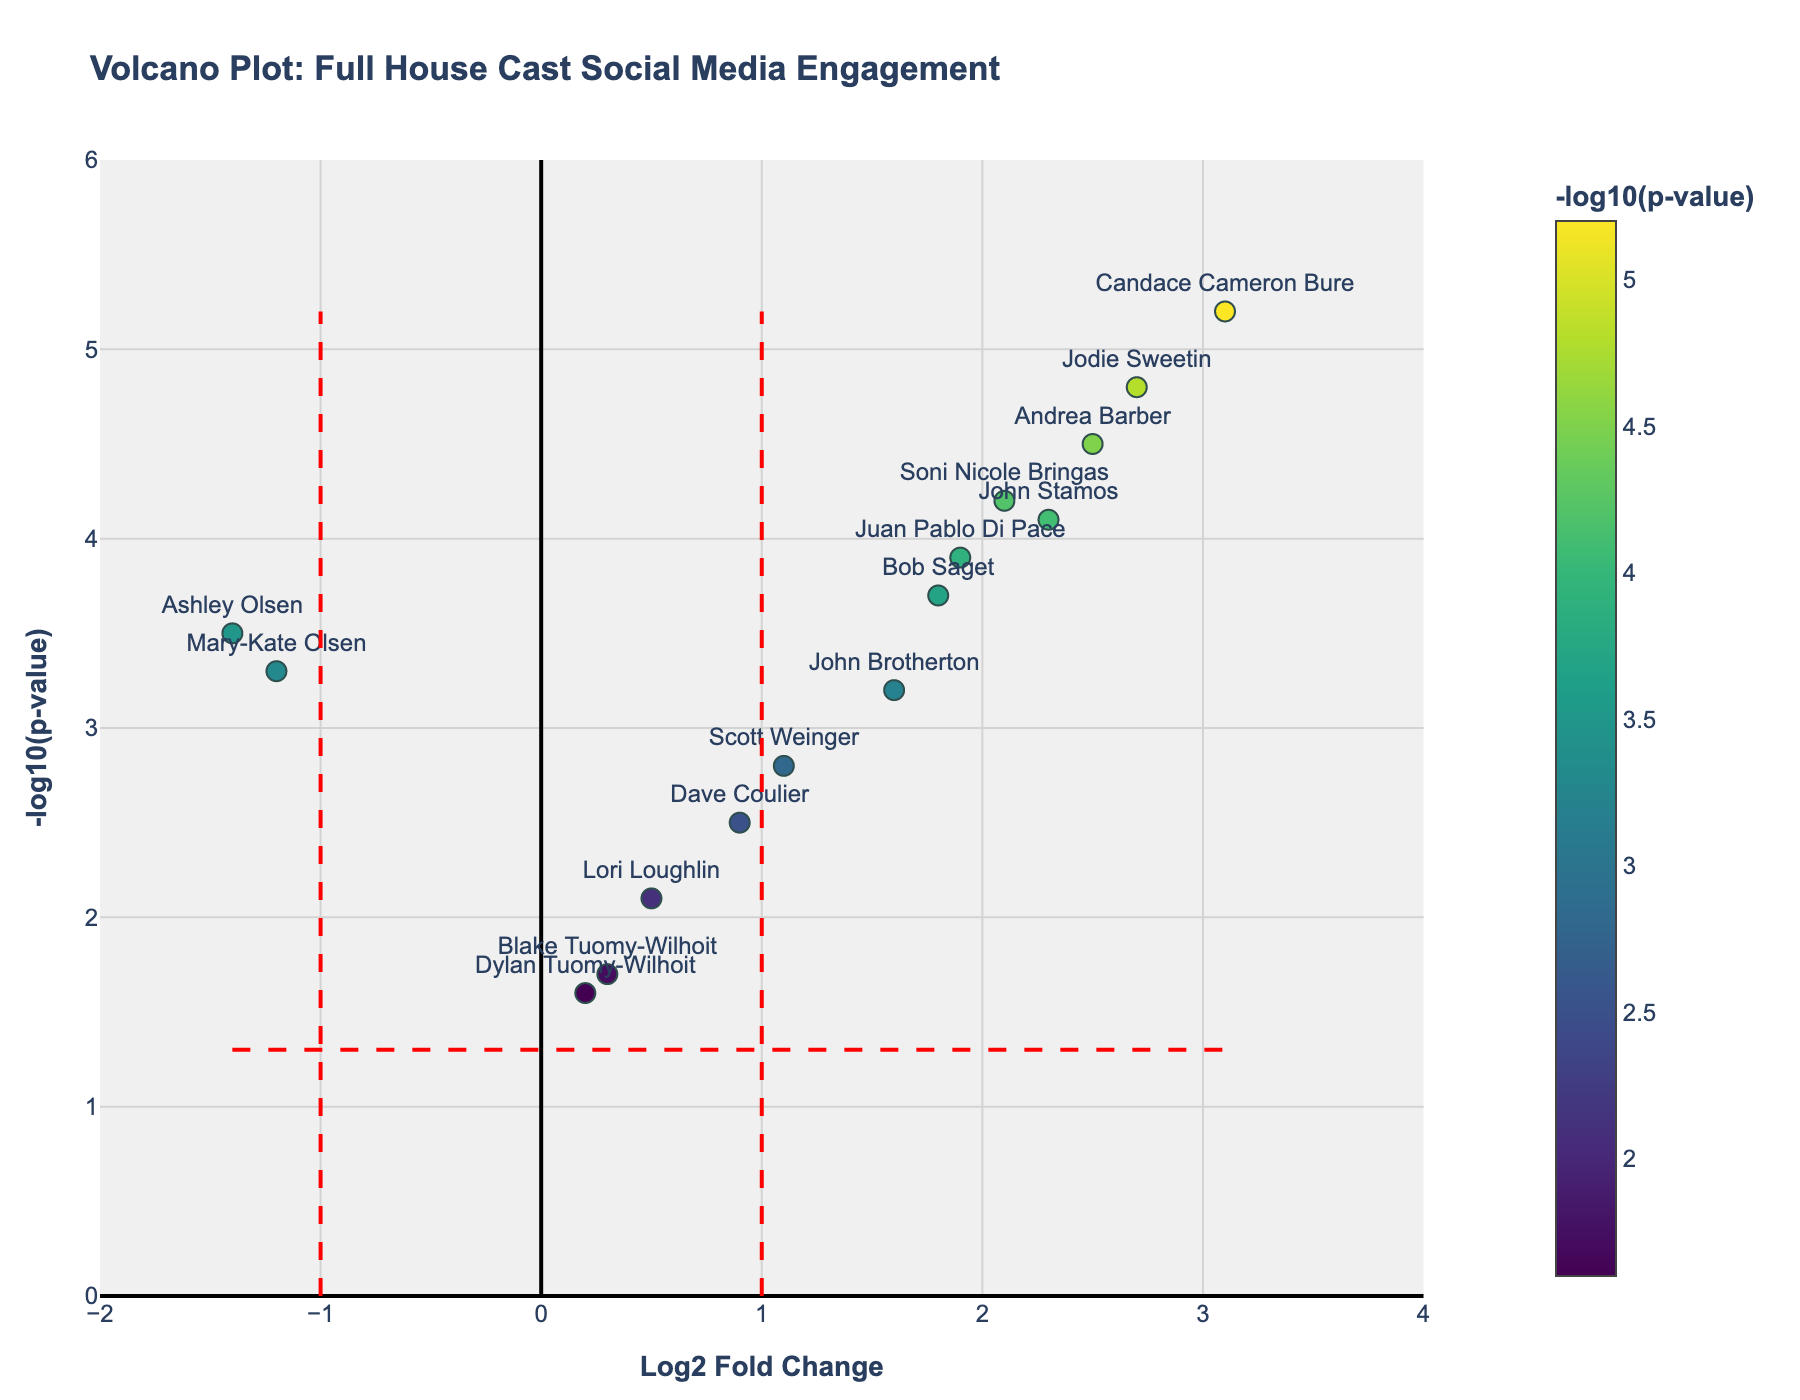Which cast member has the highest Log2 Fold Change? By looking at the x-axis, which represents Log2 Fold Change, and identifying the point farthest to the right, which is labeled with the cast member's name
Answer: Candace Cameron Bure Which cast member has the lowest Log2 Fold Change? By looking at the x-axis and identifying the point farthest to the left, which is labeled with the cast member's name
Answer: Ashley Olsen Which data point has the highest -Log10(p-value)? By looking at the y-axis, which represents -Log10(p-value), and identifying the highest point on the plot, which is labeled with the cast member's name
Answer: Candace Cameron Bure How many cast members have a Log2 Fold Change greater than 1? By counting the number of data points to the right of the vertical threshold line at Log2 Fold Change = 1
Answer: 8 Which cast member has a significant decrease in social media engagement in the Netflix revival compared to the original run? By looking for a data point to the left of the log2fc_threshold line (Log2 Fold Change < -1) and above the pvalue_threshold line (-Log10(p-value) > 1.3), indicating significance
Answer: Ashley Olsen Who has a higher engagement in the Netflix revival: John Stamos or Bob Saget? By comparing the Log2 Fold Change values on the x-axis for both John Stamos and Bob Saget and identifying which is greater
Answer: John Stamos Among the cast members, who has p-values below the significance threshold? By identifying data points above the horizontal red line indicating the p-value threshold, and listing all the cast members associated with these points
Answer: John Stamos, Bob Saget, Candace Cameron Bure, Jodie Sweetin, Mary-Kate Olsen, Ashley Olsen, Andrea Barber, Soni Nicole Bringas Which cast members fall below the Log2 Fold Change threshold of -1 and above the p-value threshold, indicating significant decrease in engagement? By checking which data points fall to the left of the vertical red line at Log2 Fold Change = -1 and are higher than the horizontal red line
Answer: Mary-Kate Olsen, Ashley Olsen 